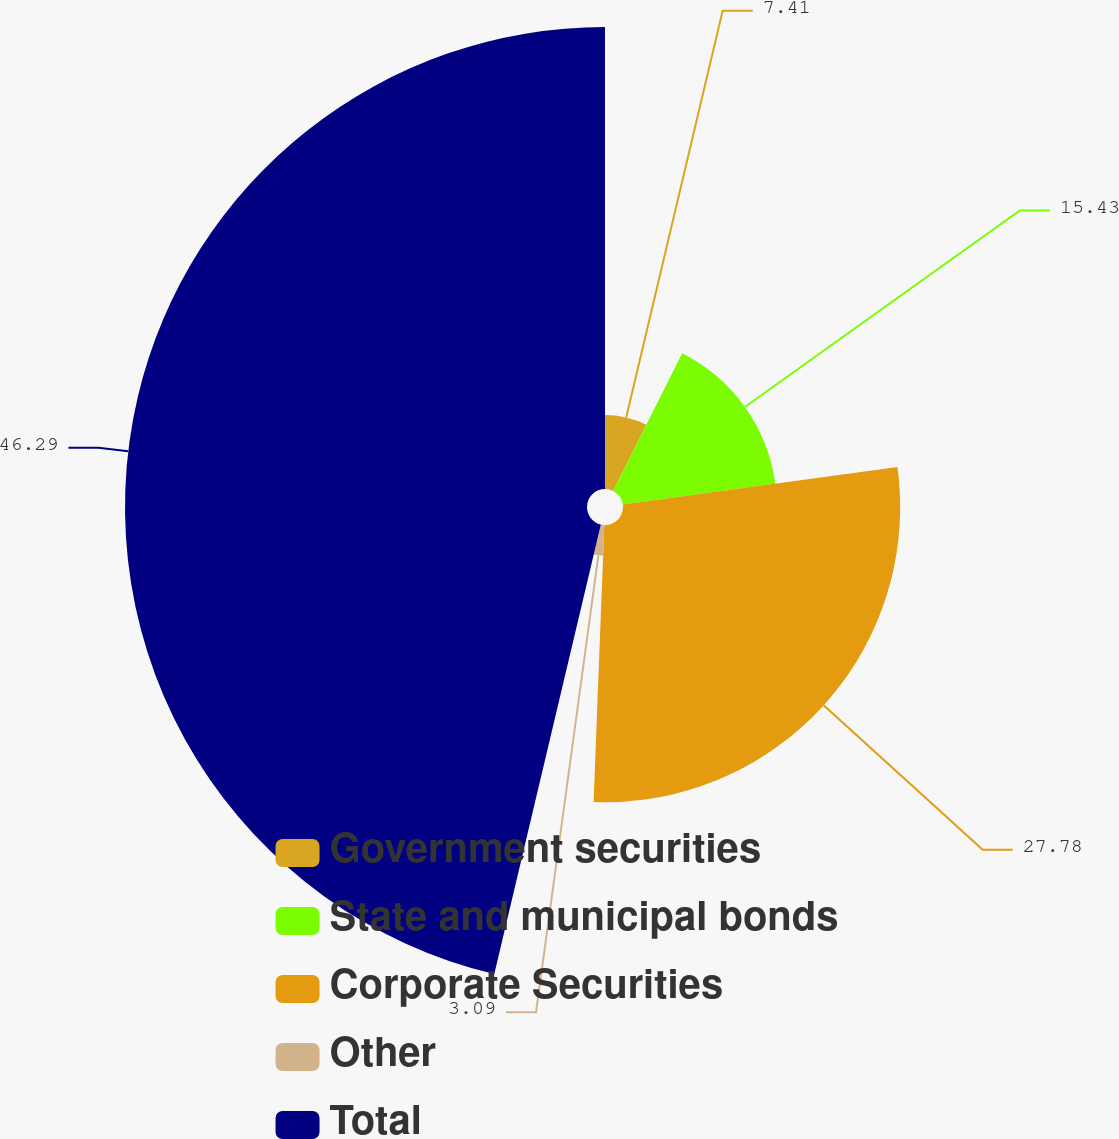<chart> <loc_0><loc_0><loc_500><loc_500><pie_chart><fcel>Government securities<fcel>State and municipal bonds<fcel>Corporate Securities<fcel>Other<fcel>Total<nl><fcel>7.41%<fcel>15.43%<fcel>27.78%<fcel>3.09%<fcel>46.3%<nl></chart> 